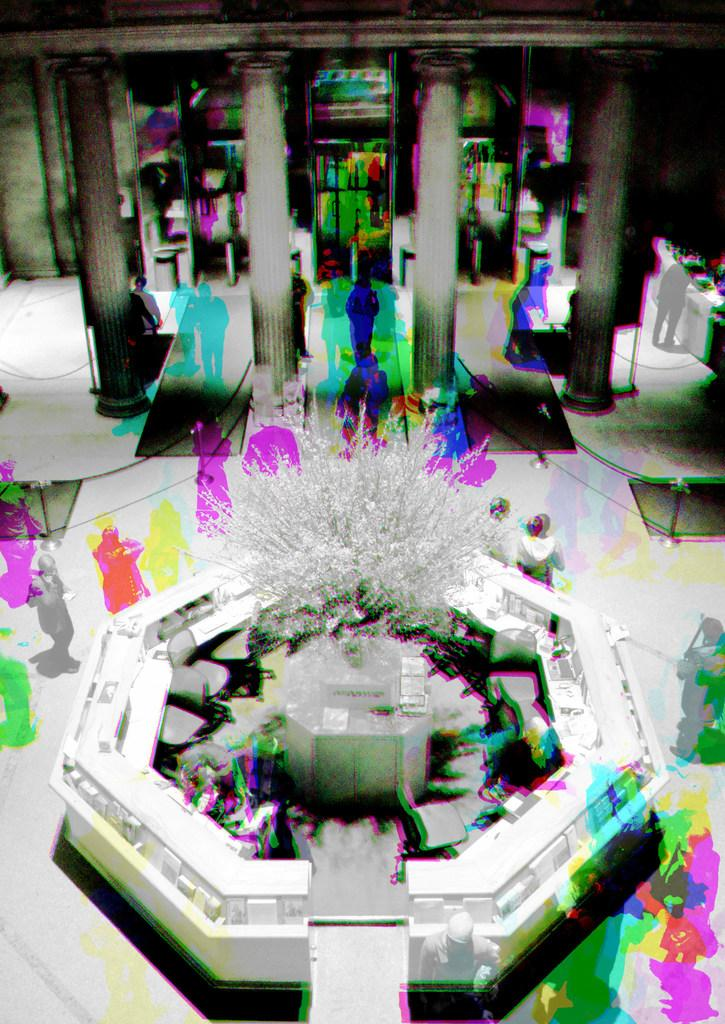What type of image is being described? The image is a graphical image. What is one of the main features of the image? There is a fountain in the image. What can be found in the foreground of the image? There is a plant in the front of the image. What architectural elements are present in the background of the image? There are pillars in the background of the image. Are there any living beings visible in the image? Yes, there are people visible in the image. Can you tell me how many gloves are being lifted by the people in the image? There is no mention of gloves or lifting in the image; it features a fountain, a plant, pillars, and people. 